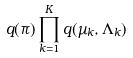<formula> <loc_0><loc_0><loc_500><loc_500>q ( \pi ) \prod _ { k = 1 } ^ { K } q ( \mu _ { k } , \Lambda _ { k } )</formula> 